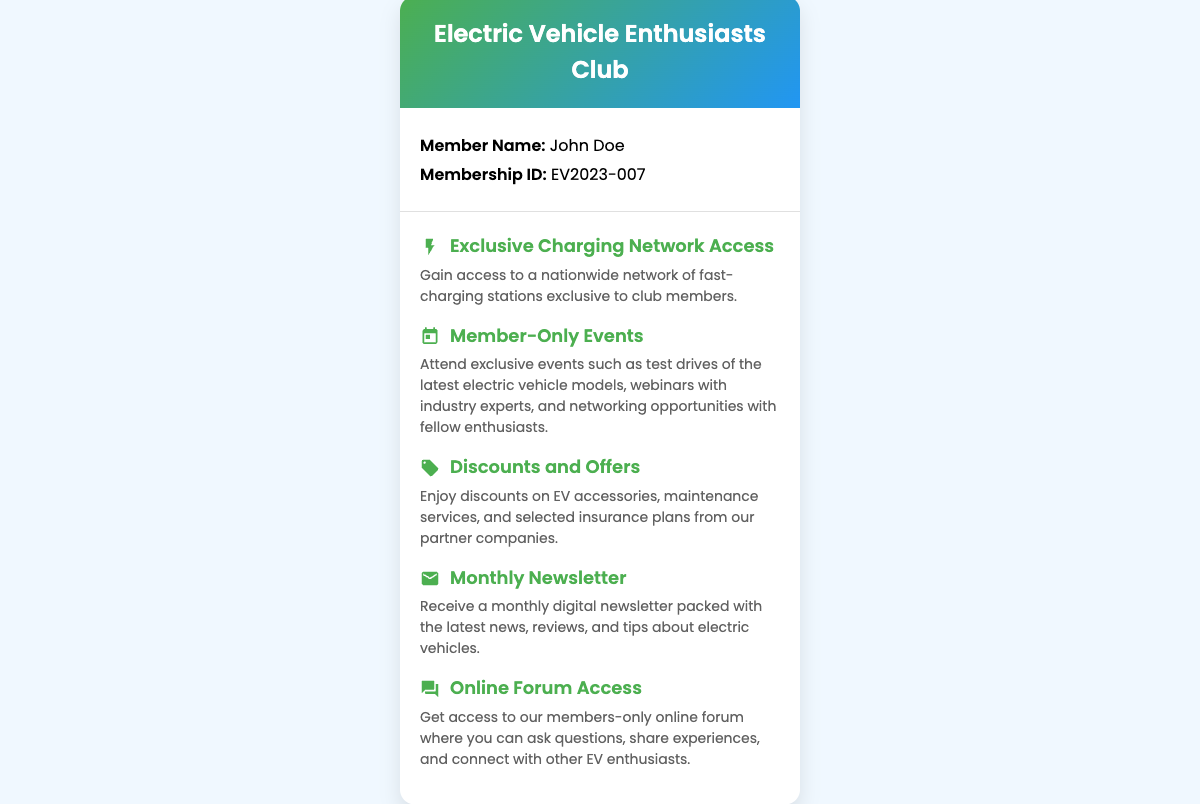What is the member's name? The document states the member's name in the member info section as John Doe.
Answer: John Doe What is the membership ID? The membership ID is explicitly mentioned in the member info section as EV2023-007.
Answer: EV2023-007 How many benefits are listed on the card? The document lists five distinct benefits within the benefits section.
Answer: 5 What benefit offers access to charging stations? The benefit that provides access to charging stations is described as "Exclusive Charging Network Access."
Answer: Exclusive Charging Network Access What type of events can members attend? Members can attend "Member-Only Events" such as test drives and webinars.
Answer: Member-Only Events Which benefit includes receiving a monthly digital publication? The benefit that includes a monthly digital publication is the "Monthly Newsletter."
Answer: Monthly Newsletter What discounts do members receive? Members receive discounts on EV accessories, maintenance services, and selected insurance plans.
Answer: Discounts on EV accessories, maintenance services, and selected insurance plans What type of forum can members access? Members can access an "Online Forum" that is exclusive to members.
Answer: Online Forum What color scheme is used in the card's header? The color scheme in the card's header features a gradient from green to blue.
Answer: Green to blue gradient 